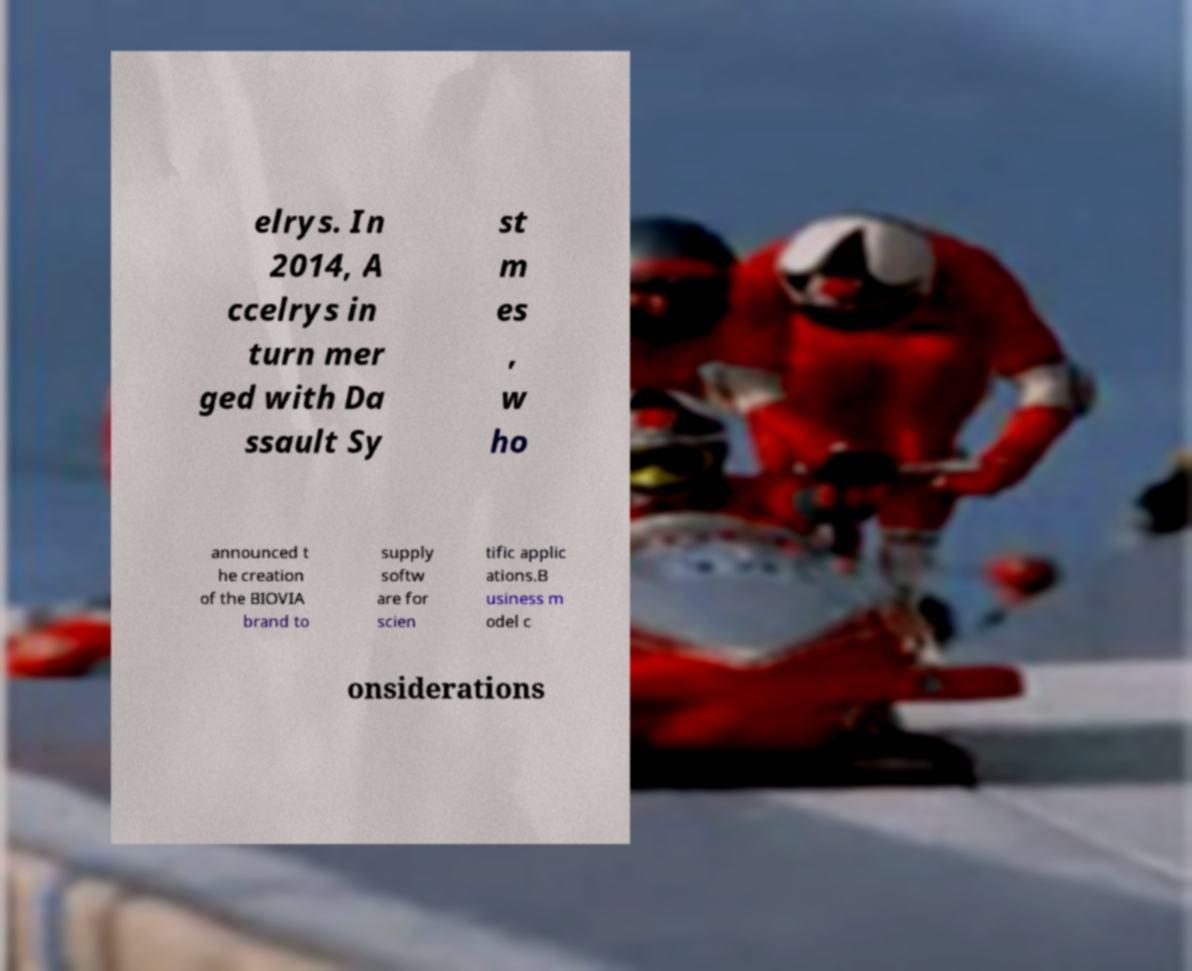Can you read and provide the text displayed in the image?This photo seems to have some interesting text. Can you extract and type it out for me? elrys. In 2014, A ccelrys in turn mer ged with Da ssault Sy st m es , w ho announced t he creation of the BIOVIA brand to supply softw are for scien tific applic ations.B usiness m odel c onsiderations 